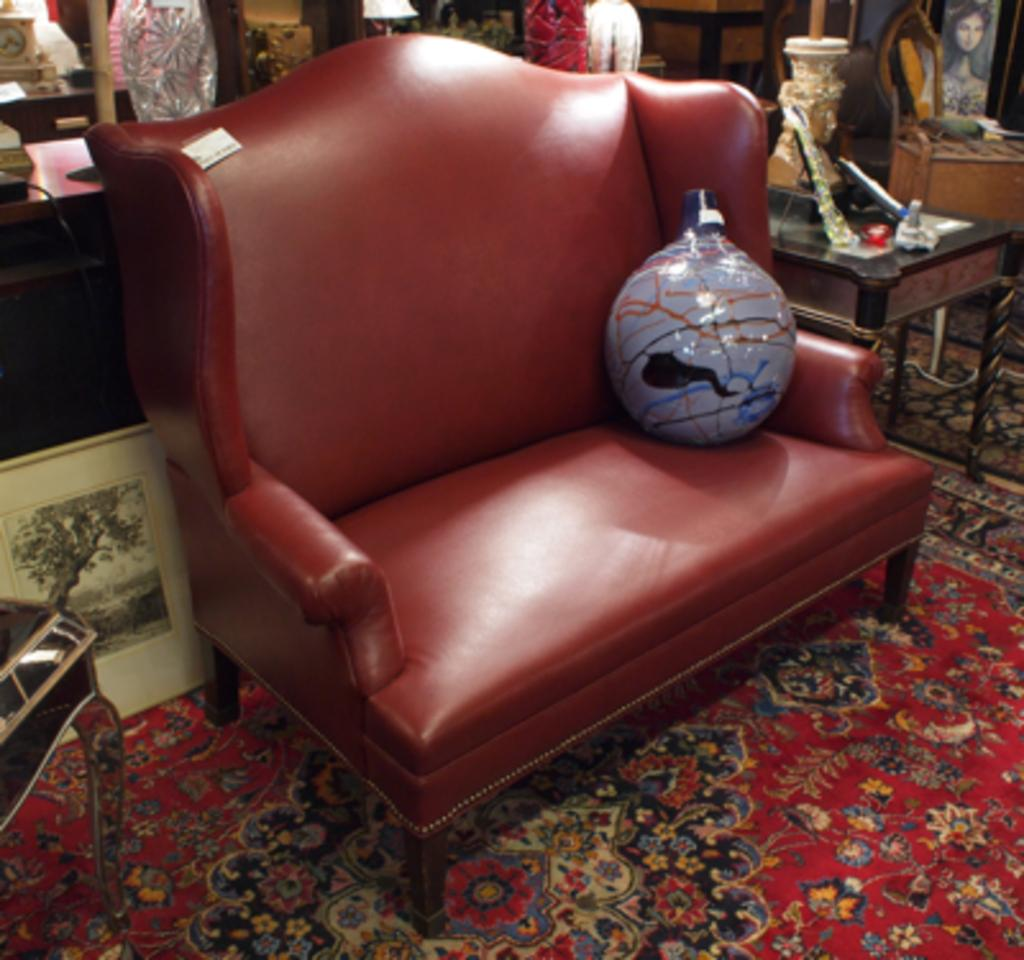What color is the sofa in the image? The sofa in the image is red. What can be seen beneath the sofa? The floor is visible in the image. What piece of furniture is present in the image besides the sofa? There is a table in the image. Are there any giants visible in the image? No, there are no giants present in the image. What type of spark can be seen coming from the table in the image? There is no spark visible in the image, as the facts provided do not mention any sparks or electrical activity. 